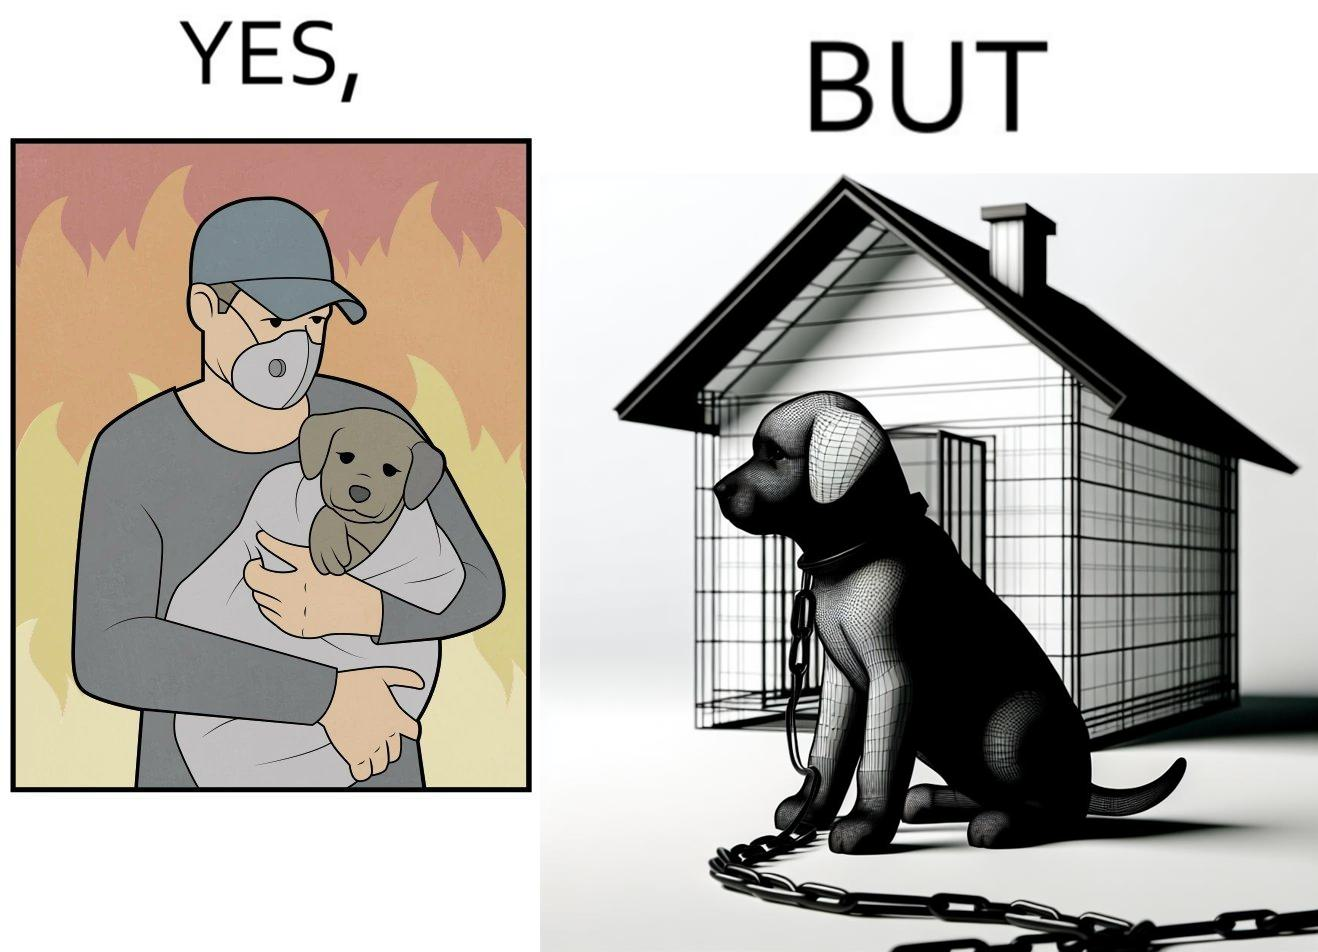Is this image satirical or non-satirical? Yes, this image is satirical. 